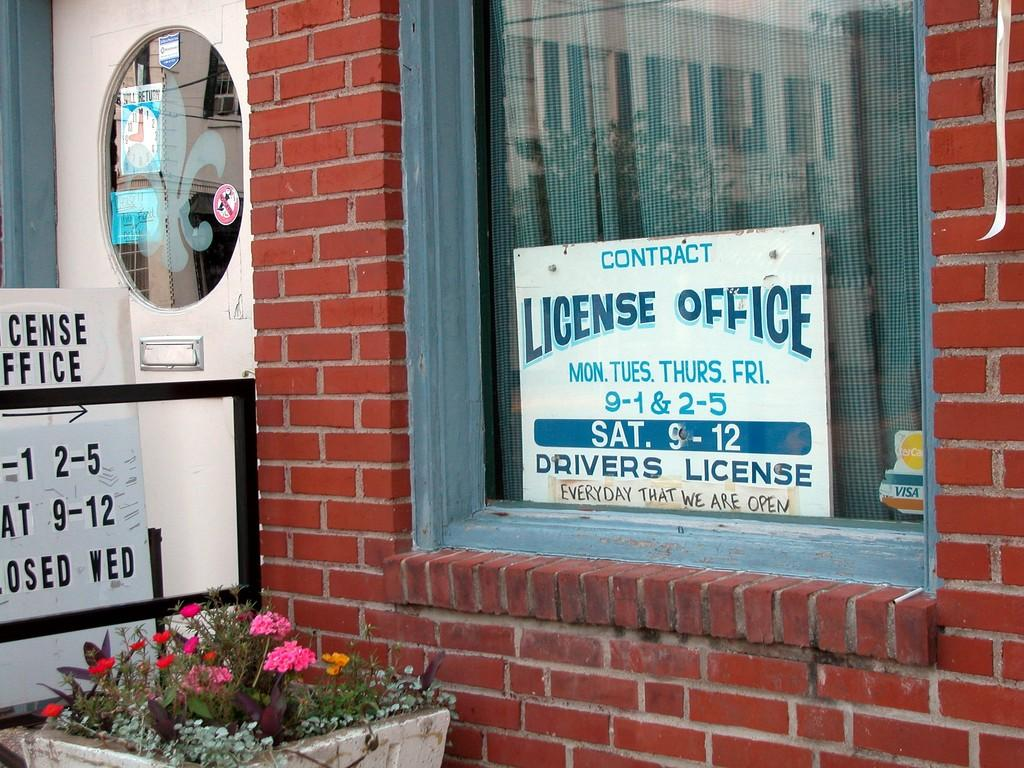What type of living organisms can be seen in the image? There are flowers and plants visible in the image. What is the color of the brick wall in the image? The brick wall in the image is red. What can be seen through the window in the image? Curtains are visible through the window in the image. What type of signage is present in the image? There is a sign board in the image. What type of feather can be seen floating in the image? There is no feather present in the image. How does the brick wall react to the presence of the flowers in the image? The brick wall is an inanimate object and does not have the ability to react. 